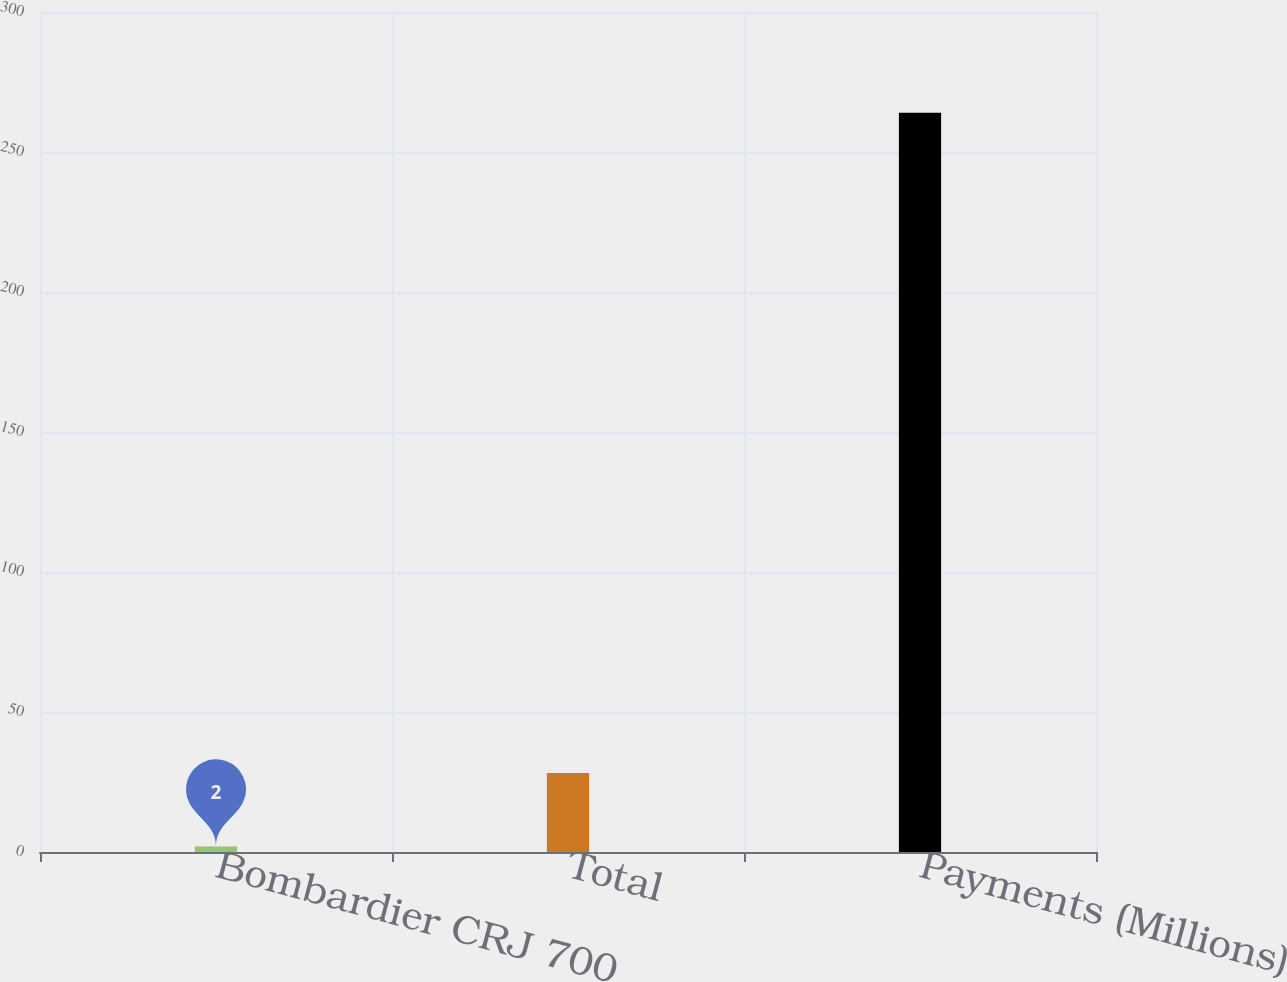Convert chart to OTSL. <chart><loc_0><loc_0><loc_500><loc_500><bar_chart><fcel>Bombardier CRJ 700<fcel>Total<fcel>Payments (Millions)<nl><fcel>2<fcel>28.2<fcel>264<nl></chart> 